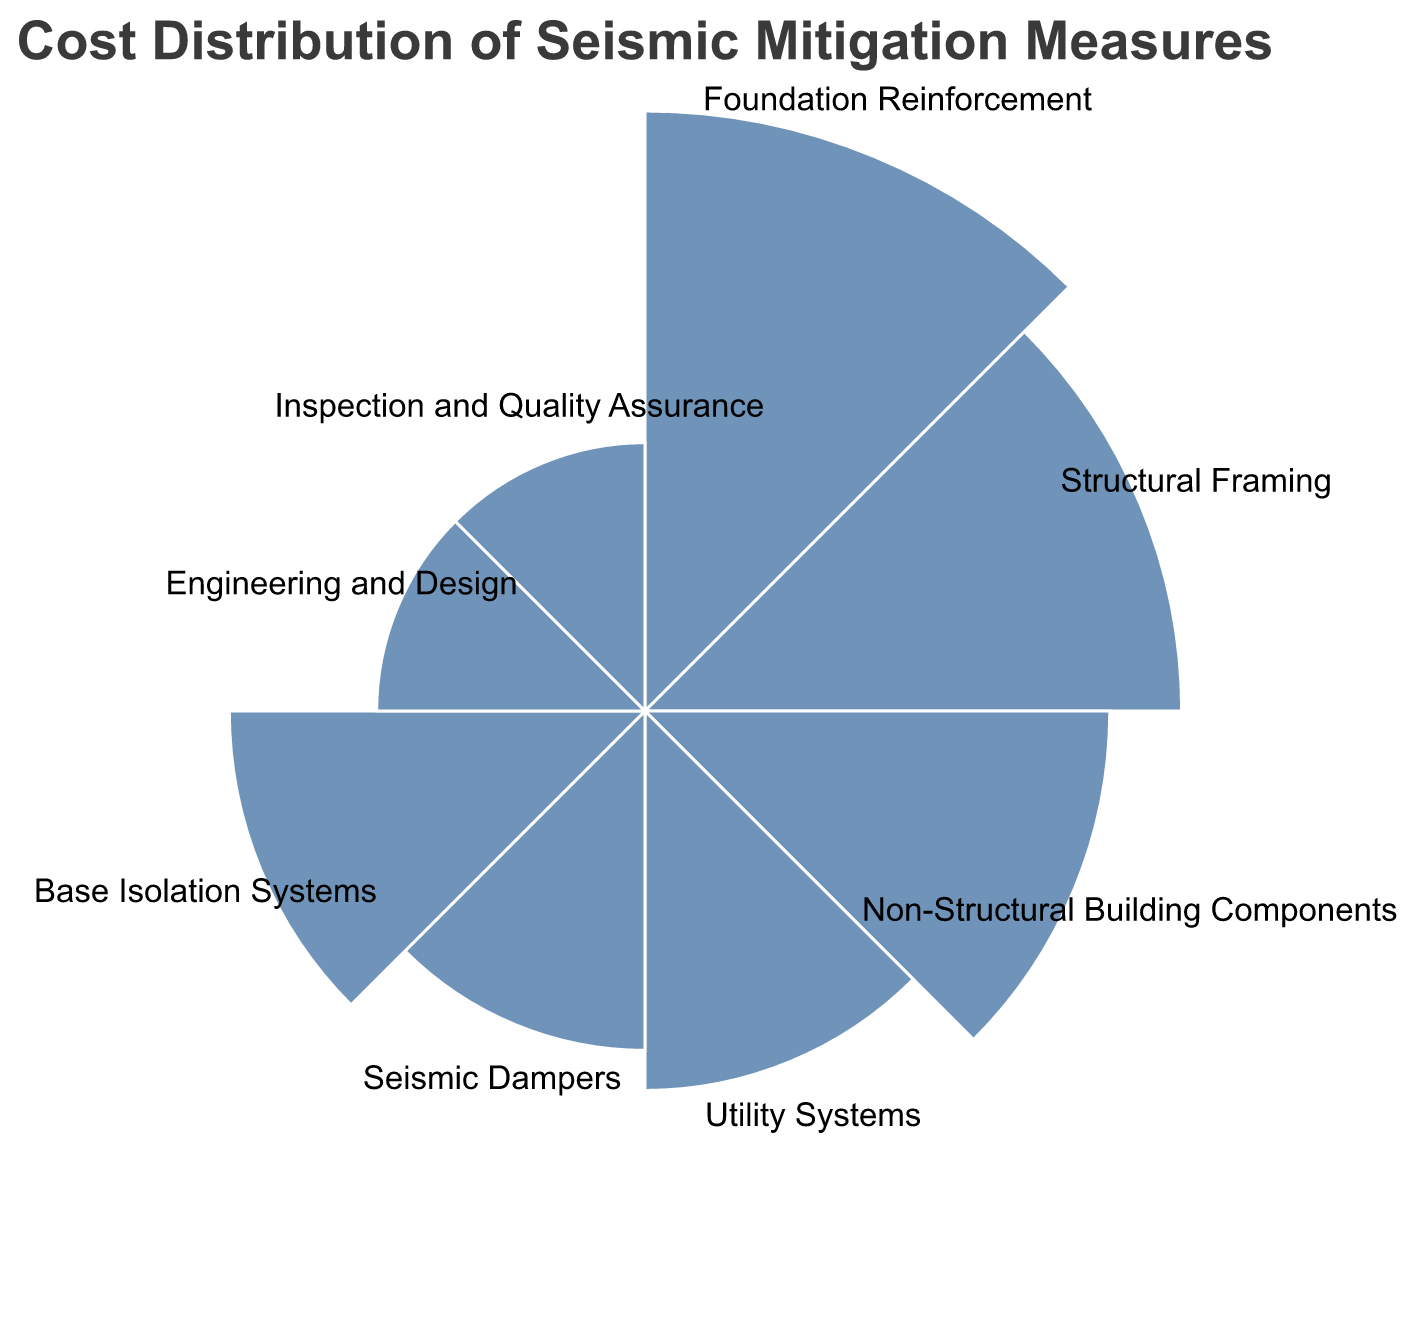What category has the highest percentage in cost distribution? To determine which category has the highest percentage, look for the largest segment of the polar chart. "Foundation Reinforcement" occupies the largest segment.
Answer: Foundation Reinforcement Which category represents 20% of the cost distribution? Match the percentage provided (20%) with the corresponding segment on the chart. The "Structural Framing" category aligns with 20%.
Answer: Structural Framing How much higher is the percentage for Foundation Reinforcement compared to Non-Structural Building Components? Foundation Reinforcement is at 25% and Non-Structural Building Components is at 15%. The difference is 25% - 15% = 10%.
Answer: 10% What is the combined percentage of Inspection and Quality Assurance and Engineering and Design costs? Both categories have 5% each. Adding them gives 5% + 5% = 10%.
Answer: 10% Rank the categories by their percentage in descending order. To rank the categories, list them from the highest to lowest percentage: Foundation Reinforcement (25%), Structural Framing (20%), Non-Structural Building Components (15%), Base Isolation Systems (12%), Utility Systems (10%), Seismic Dampers (8%), Engineering and Design (5%), Inspection and Quality Assurance (5%).
Answer: Foundation Reinforcement, Structural Framing, Non-Structural Building Components, Base Isolation Systems, Utility Systems, Seismic Dampers, Engineering and Design, Inspection and Quality Assurance Which categories combined make up 50% of the total cost distribution? Adding the top percentages until we reach or exceed 50%: Foundation Reinforcement (25%) + Structural Framing (20%) + Non-Structural Building Components (15%) = 60%. We have already surpassed 50% with these three categories.
Answer: Foundation Reinforcement, Structural Framing, Non-Structural Building Components What is the smallest category in terms of cost percentage? Identify the category with the smallest segment in the polar chart. Both Inspection and Quality Assurance, and Engineering and Design have the smallest segments at 5% each.
Answer: Inspection and Quality Assurance, Engineering and Design How much higher is the combined percentage of Utility Systems and Seismic Dampers compared to Base Isolation Systems? Utility Systems (10%) + Seismic Dampers (8%) = 18%. Base Isolation Systems is 12%. The difference is 18% - 12% = 6%.
Answer: 6% Which categories fall below the 10% threshold? Categories with percentages less than 10% are Utility Systems (10%) is on the threshold but not below, so the remaining ones are Seismic Dampers (8%), Engineering and Design (5%), Inspection and Quality Assurance (5%).
Answer: Seismic Dampers, Engineering and Design, Inspection and Quality Assurance 